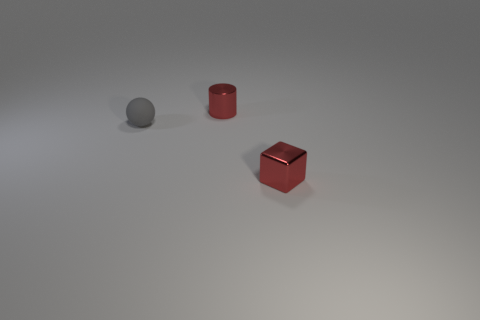Do the gray rubber object that is to the left of the red cylinder and the shiny object that is behind the small cube have the same size?
Keep it short and to the point. Yes. The small rubber object that is left of the small red metal thing that is in front of the ball is what shape?
Your answer should be very brief. Sphere. Are there the same number of tiny gray spheres that are to the right of the small gray object and big yellow shiny cubes?
Keep it short and to the point. Yes. What material is the object that is behind the small thing that is left of the red metallic object that is behind the tiny block made of?
Your answer should be very brief. Metal. Is there another gray matte sphere of the same size as the gray ball?
Your answer should be compact. No. What number of cylinders are small red things or tiny rubber objects?
Keep it short and to the point. 1. Is the number of gray spheres that are behind the tiny sphere the same as the number of metal cylinders to the right of the small cube?
Your response must be concise. Yes. How many red metal cubes are on the right side of the tiny red metallic object that is left of the tiny metallic object that is in front of the tiny gray rubber object?
Keep it short and to the point. 1. What is the shape of the metallic thing that is the same color as the shiny cube?
Offer a terse response. Cylinder. There is a sphere; is it the same color as the tiny object behind the tiny matte object?
Make the answer very short. No. 